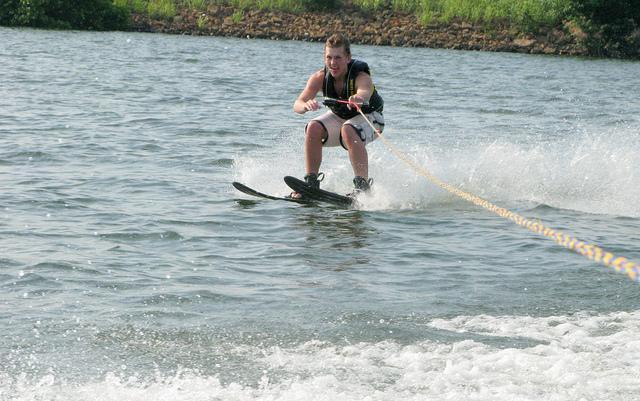How many clock faces are visible in this photo?
Give a very brief answer. 0. 